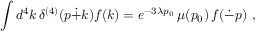Convert formula to latex. <formula><loc_0><loc_0><loc_500><loc_500>\int d ^ { 4 } k \, \delta ^ { ( 4 ) } ( p \dot { + } k ) f ( k ) = e ^ { - 3 \lambda p _ { 0 } } \, \mu ( p _ { 0 } ) \, f ( \dot { - } p ) ,</formula> 